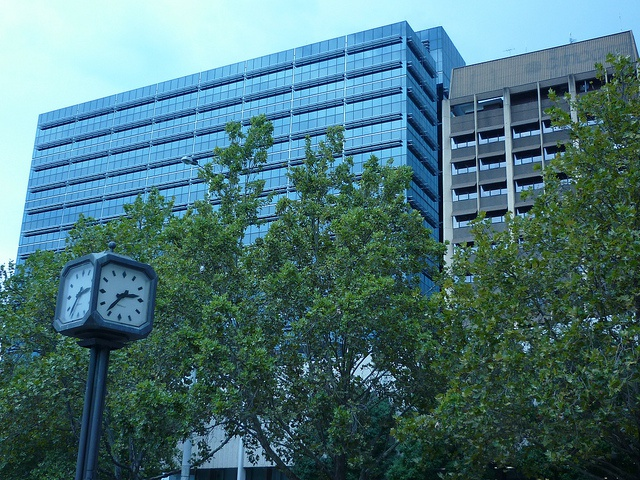Describe the objects in this image and their specific colors. I can see a clock in white, gray, navy, blue, and lightblue tones in this image. 